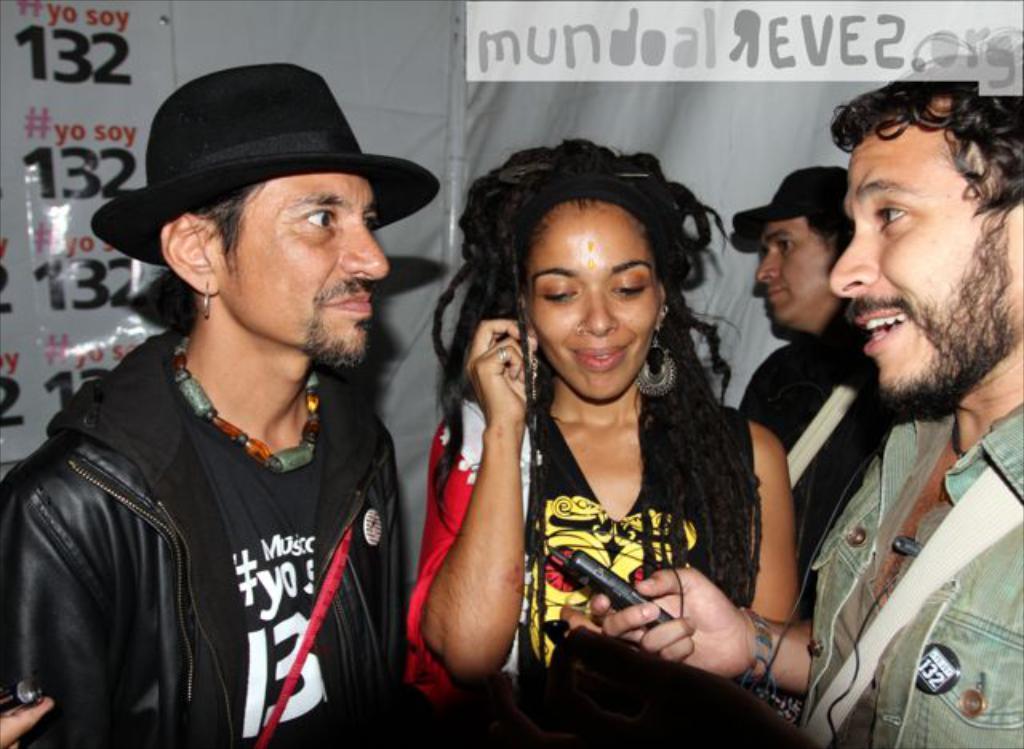Describe this image in one or two sentences. In this picture I can see there are three people standing and the people at left are wearing black coats, dresses, caps. They are smiling and in the backdrop there is a man standing and he is also wearing a cap. There is a wall in the backdrop. 